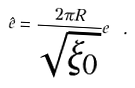Convert formula to latex. <formula><loc_0><loc_0><loc_500><loc_500>\hat { e } = \frac { 2 \pi R } { \sqrt { \xi _ { 0 } } } e \ .</formula> 